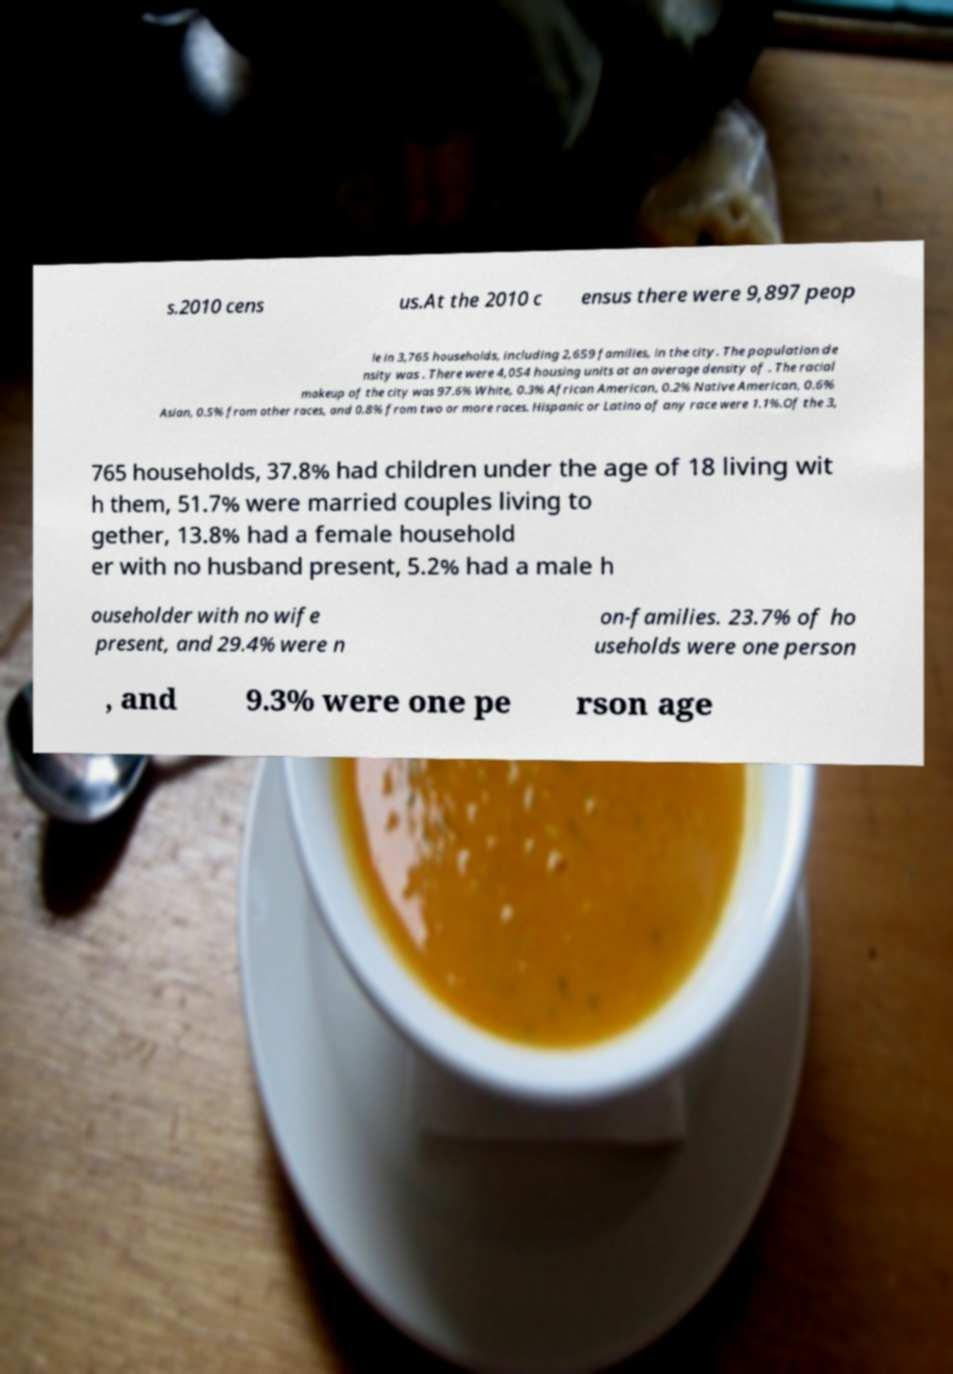Can you read and provide the text displayed in the image?This photo seems to have some interesting text. Can you extract and type it out for me? s.2010 cens us.At the 2010 c ensus there were 9,897 peop le in 3,765 households, including 2,659 families, in the city. The population de nsity was . There were 4,054 housing units at an average density of . The racial makeup of the city was 97.6% White, 0.3% African American, 0.2% Native American, 0.6% Asian, 0.5% from other races, and 0.8% from two or more races. Hispanic or Latino of any race were 1.1%.Of the 3, 765 households, 37.8% had children under the age of 18 living wit h them, 51.7% were married couples living to gether, 13.8% had a female household er with no husband present, 5.2% had a male h ouseholder with no wife present, and 29.4% were n on-families. 23.7% of ho useholds were one person , and 9.3% were one pe rson age 